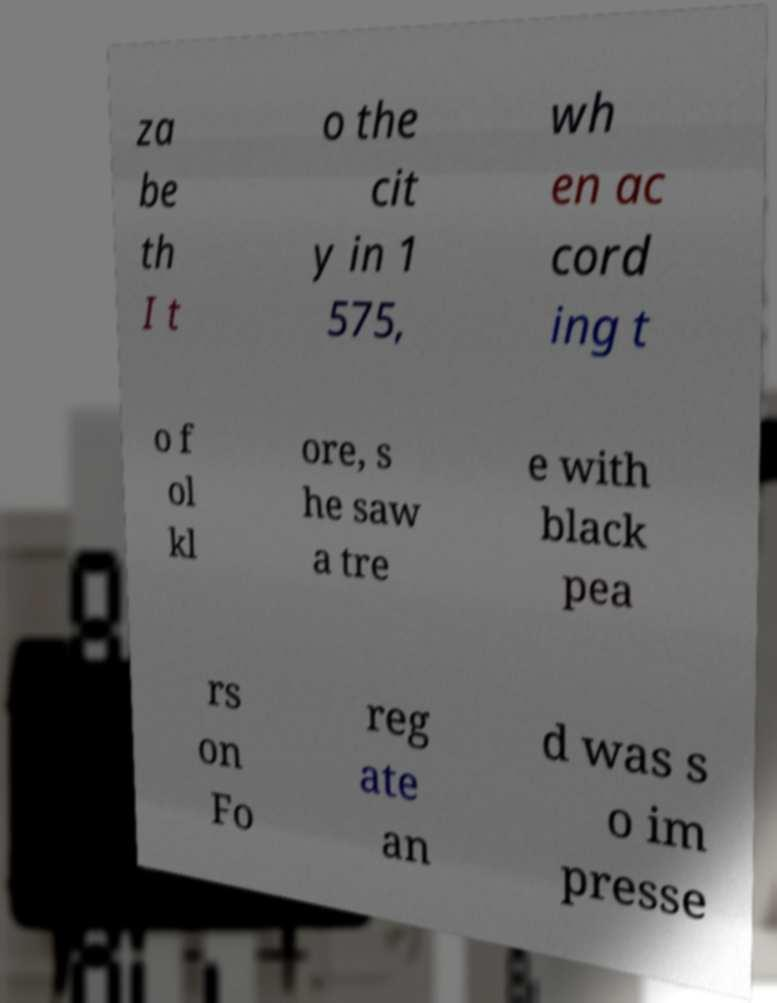I need the written content from this picture converted into text. Can you do that? za be th I t o the cit y in 1 575, wh en ac cord ing t o f ol kl ore, s he saw a tre e with black pea rs on Fo reg ate an d was s o im presse 